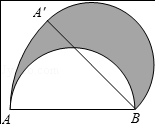In the given figure, if a semicircle with AB as its diameter and a length of 4.0 units rotates clockwise about point B by 45.0 degrees, causing point A to move to position A', what is the area of the shaded region? The shaded region in the image represents the area swept by the rotation of section AB of the semicircle. Essentially, it forms a sector. The formula for the area of a sector is (theta/360) * pi * r^2, where theta is the angle in degrees (45 degrees here) and r is the radius (4 units in this case). Therefore, the area is (45/360) * pi * 4^2 = 2pi square units. We determine that the shaded region, which encapsulates this sector due to the specific rotation of 45 degrees, has a calculated area of 2pi, exactly matching option B. 